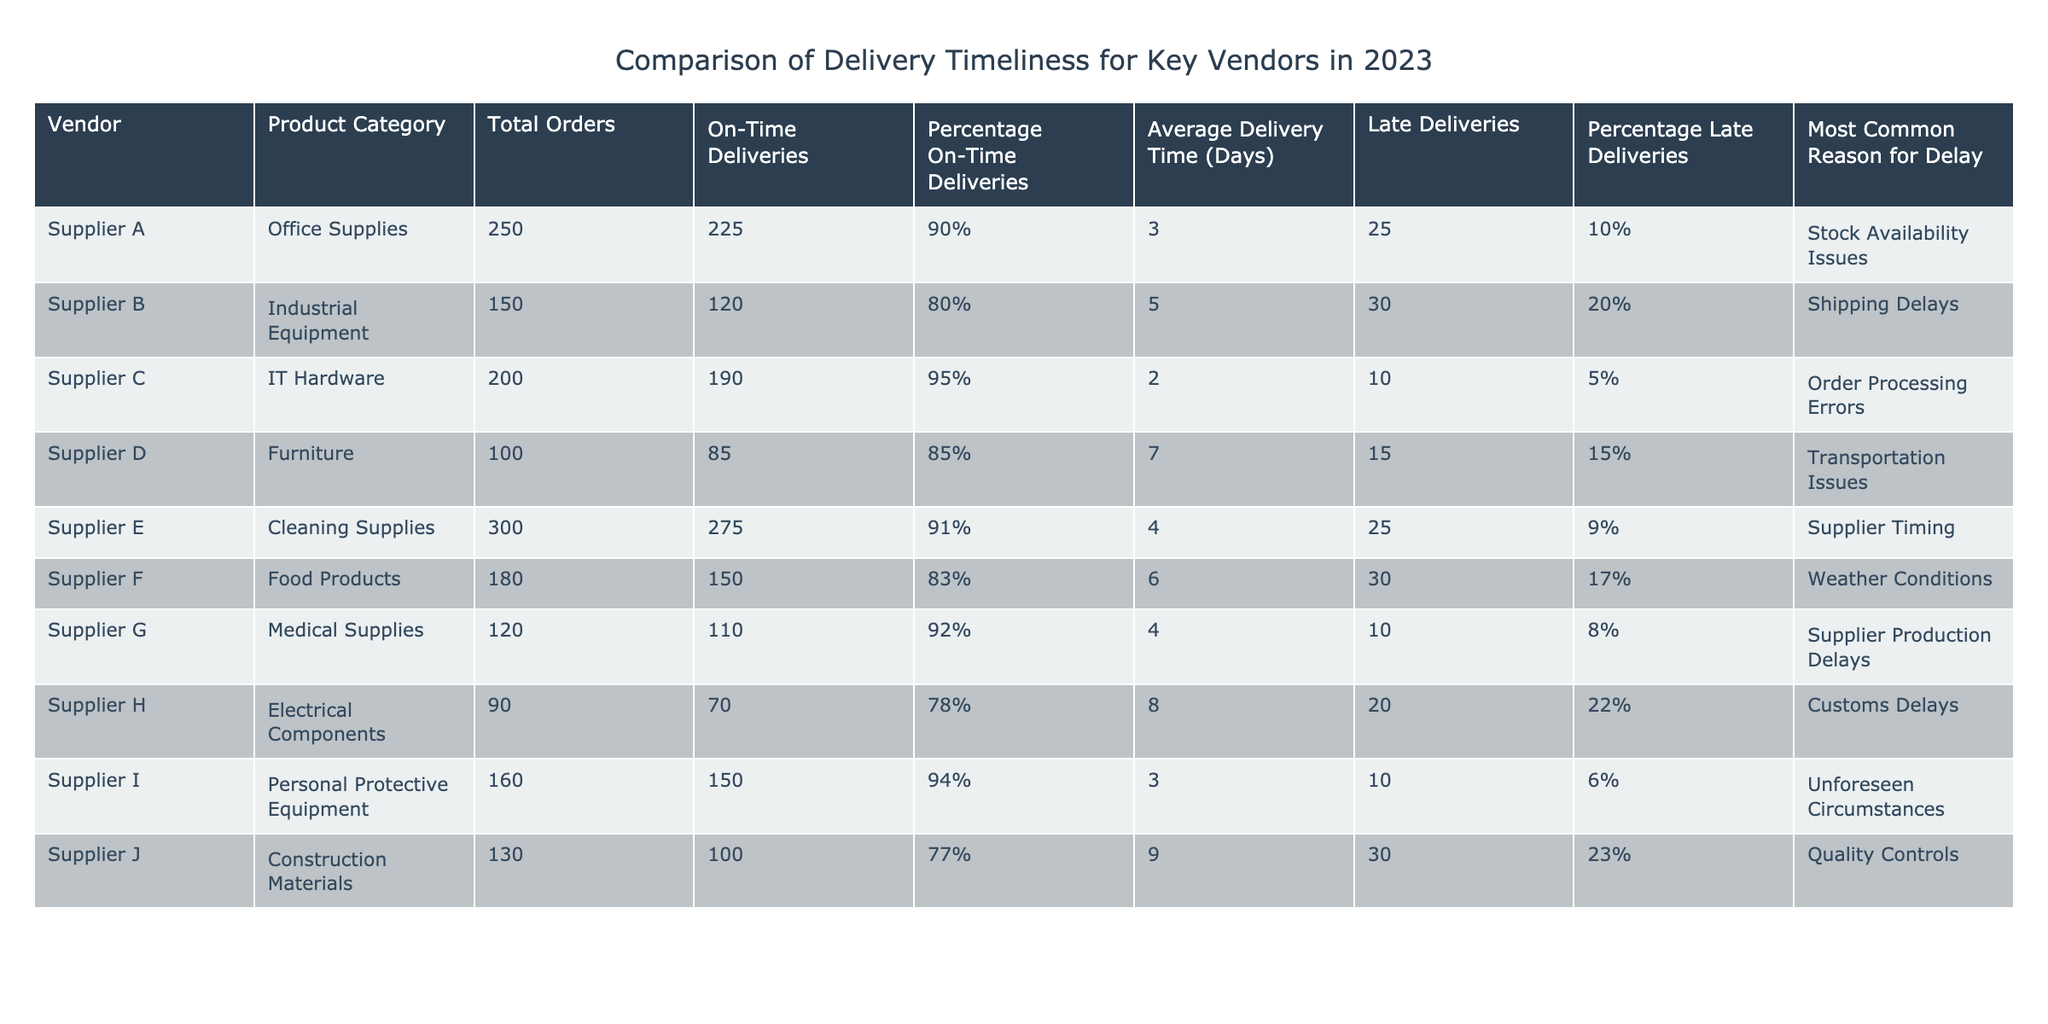What is the percentage of on-time deliveries for Supplier C? The table shows that Supplier C has a percentage of on-time deliveries listed as 95%.
Answer: 95% Which supplier had the highest average delivery time? By comparing the average delivery times of all suppliers, Supplier H has the highest average delivery time at 8 days.
Answer: Supplier H How many total orders did Supplier E have? The table indicates that Supplier E had a total of 300 orders.
Answer: 300 What is the difference in the percentage of on-time deliveries between Supplier B and Supplier G? Supplier B's percentage of on-time deliveries is 80%, while Supplier G's is 92%. The difference is 92% - 80% = 12%.
Answer: 12% Is it true that Supplier D has more late deliveries than on-time deliveries? Supplier D had 15 late deliveries and 85 on-time deliveries. Since 15 is less than 85, the statement is false.
Answer: No What is the average delivery time for all suppliers? To find the average, we add the average delivery times of each supplier: (3 + 5 + 2 + 7 + 4 + 6 + 4 + 8 + 3 + 9) = 51 days. Then we divide by the number of suppliers (10), which equals 51 / 10 = 5.1 days.
Answer: 5.1 days Which supplier has the least percentage of late deliveries? Examining the table, Supplier I has the least percentage of late deliveries at 6%.
Answer: Supplier I If we sum the total orders from Suppliers C, E, and G, what is the result? Total orders are calculated as follows: Supplier C (200) + Supplier E (300) + Supplier G (120) = 620 total orders.
Answer: 620 How many suppliers had an on-time delivery percentage of 90% or higher? Suppliers A, C, E, and G had on-time delivery percentages of 90%, 95%, 91%, and 92%, respectively. Therefore, there are four suppliers with 90% or higher.
Answer: 4 What is the most common reason for delay among all suppliers? The reasons for delay vary for each supplier. The most frequent reason observed is "Supplier Timing," which is the reason mentioned for Supplier E, but no other reason dominates across multiple suppliers.
Answer: Supplier Timing 